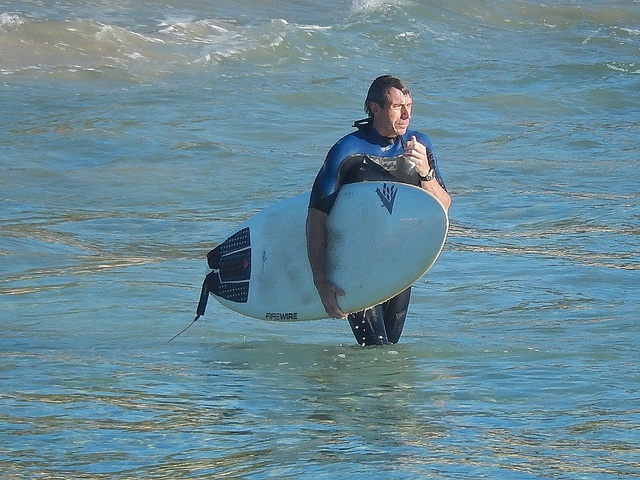Describe the objects in this image and their specific colors. I can see surfboard in gray, teal, and black tones and people in gray, black, navy, and darkblue tones in this image. 